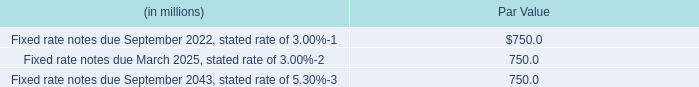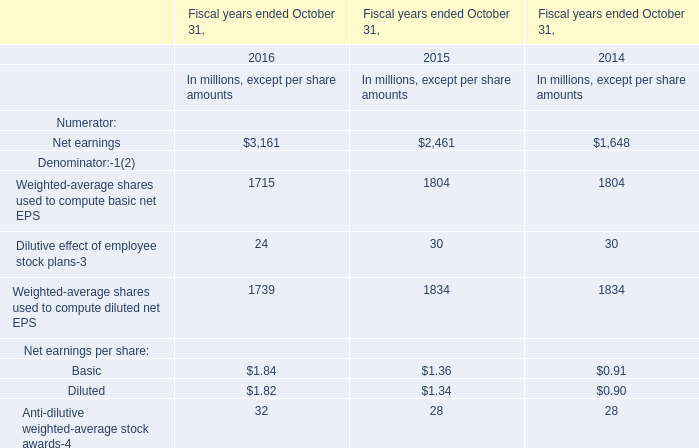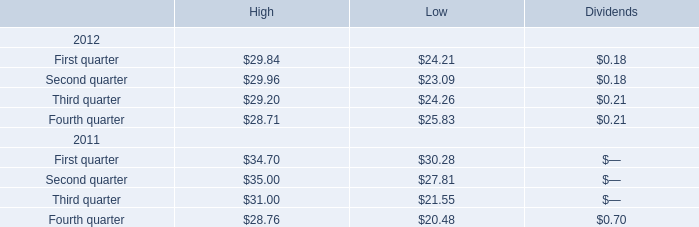The total amount of which section ranks firs t in 2012 for high? 
Answer: Second quarter. 